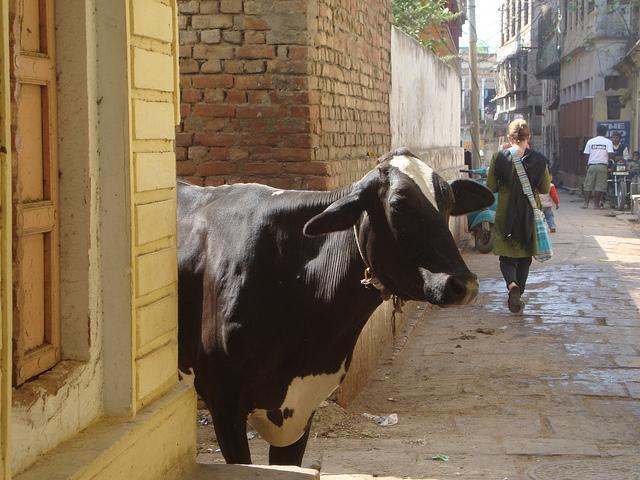How many bikes can you spot?
Give a very brief answer. 0. 